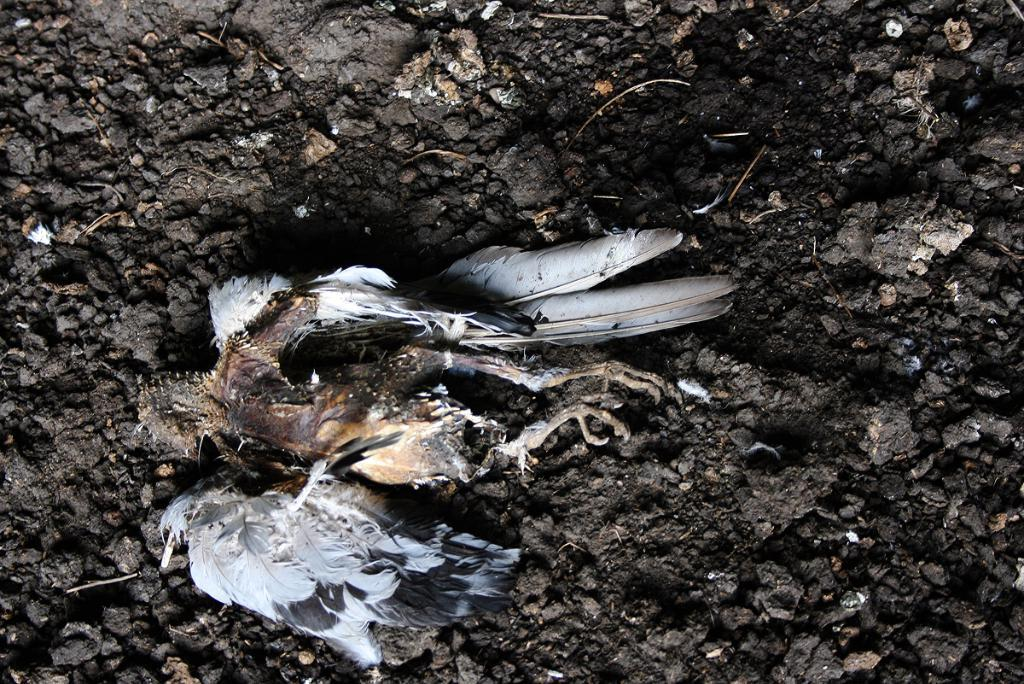What is the main subject of the image? The main subject of the image is a dead bird. What is the bird lying on in the image? The bird is in black soil. What trick did the bird perform before it died in the image? There is no indication of a trick or any performance in the image; it simply shows a dead bird lying in black soil. 